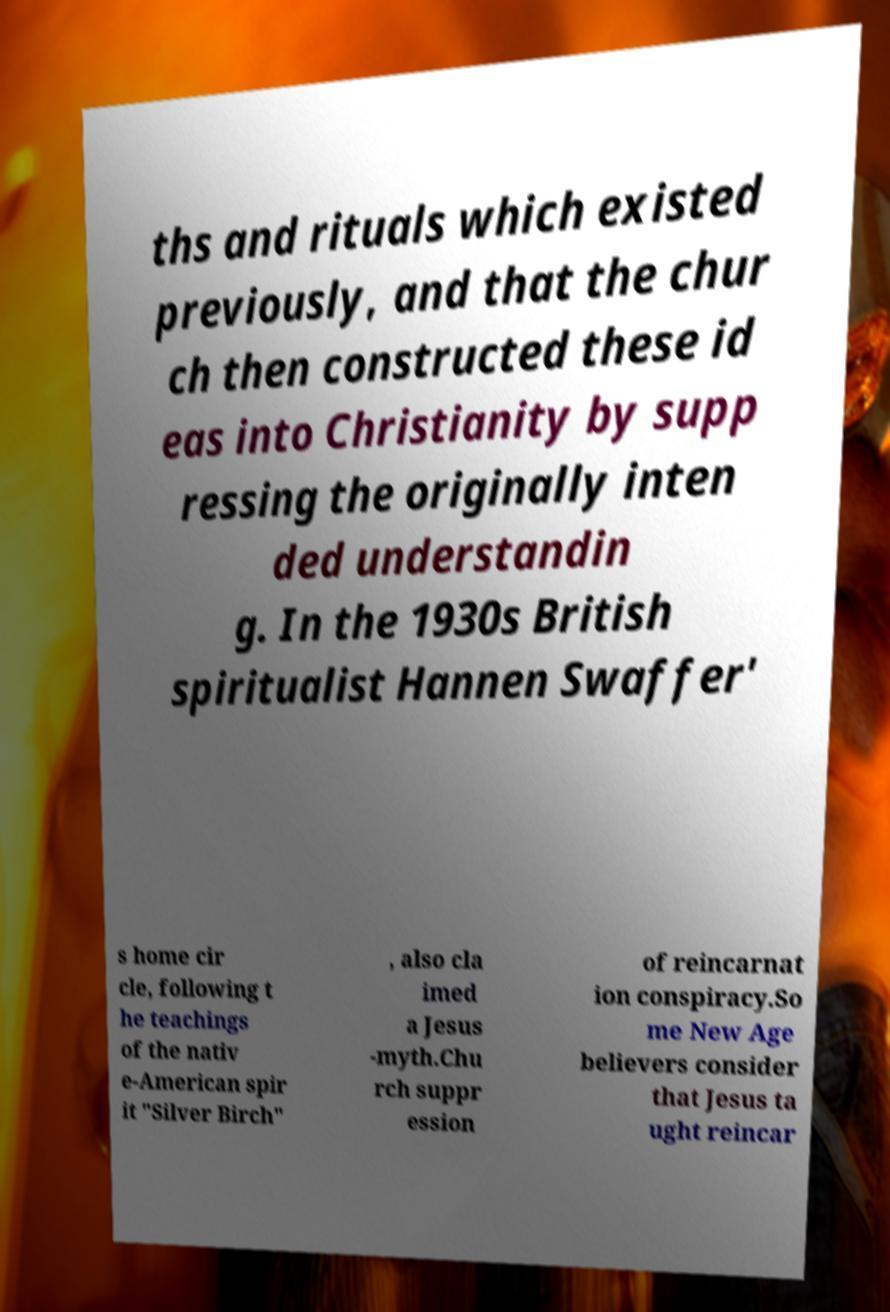Please read and relay the text visible in this image. What does it say? ths and rituals which existed previously, and that the chur ch then constructed these id eas into Christianity by supp ressing the originally inten ded understandin g. In the 1930s British spiritualist Hannen Swaffer' s home cir cle, following t he teachings of the nativ e-American spir it "Silver Birch" , also cla imed a Jesus -myth.Chu rch suppr ession of reincarnat ion conspiracy.So me New Age believers consider that Jesus ta ught reincar 